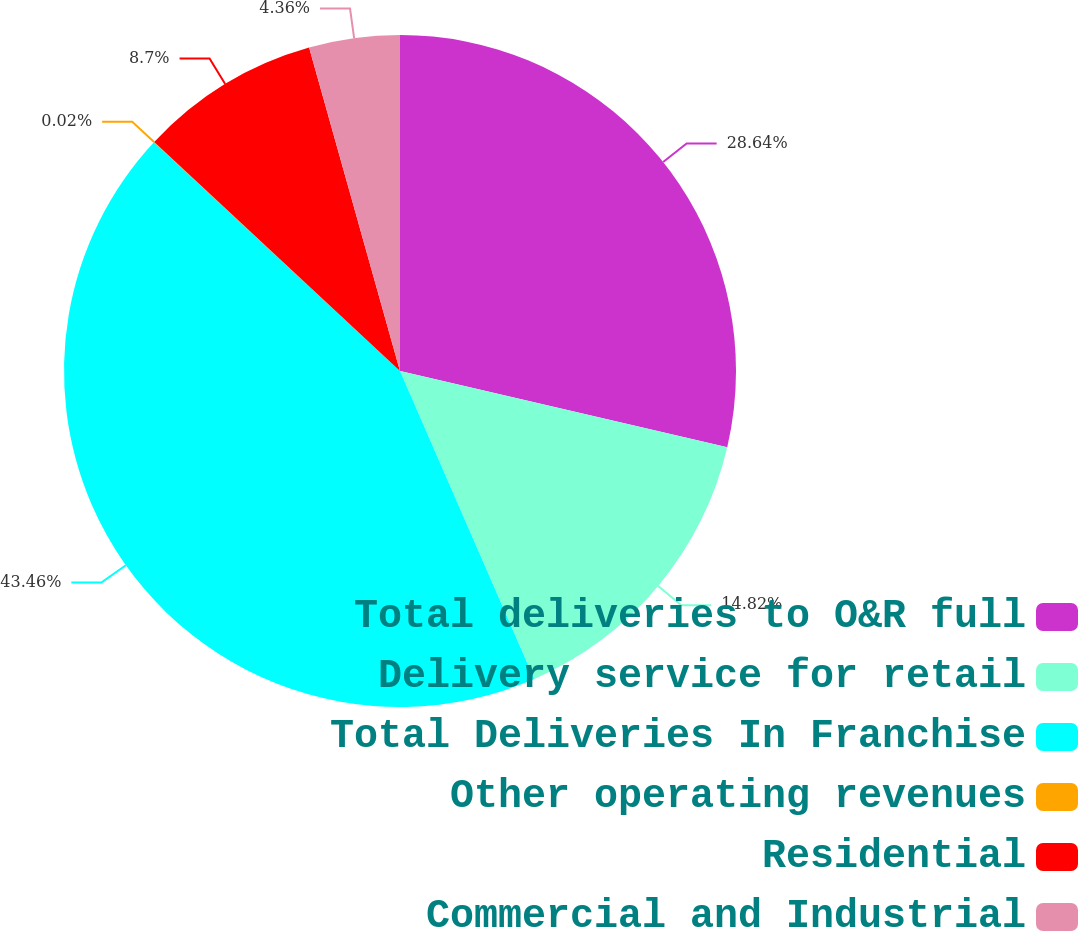Convert chart. <chart><loc_0><loc_0><loc_500><loc_500><pie_chart><fcel>Total deliveries to O&R full<fcel>Delivery service for retail<fcel>Total Deliveries In Franchise<fcel>Other operating revenues<fcel>Residential<fcel>Commercial and Industrial<nl><fcel>28.64%<fcel>14.82%<fcel>43.46%<fcel>0.02%<fcel>8.7%<fcel>4.36%<nl></chart> 